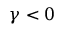Convert formula to latex. <formula><loc_0><loc_0><loc_500><loc_500>\gamma < 0</formula> 